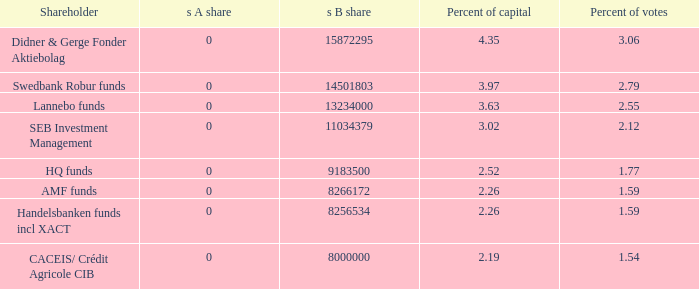What is the s B share for the shareholder that has 2.55 percent of votes?  13234000.0. 